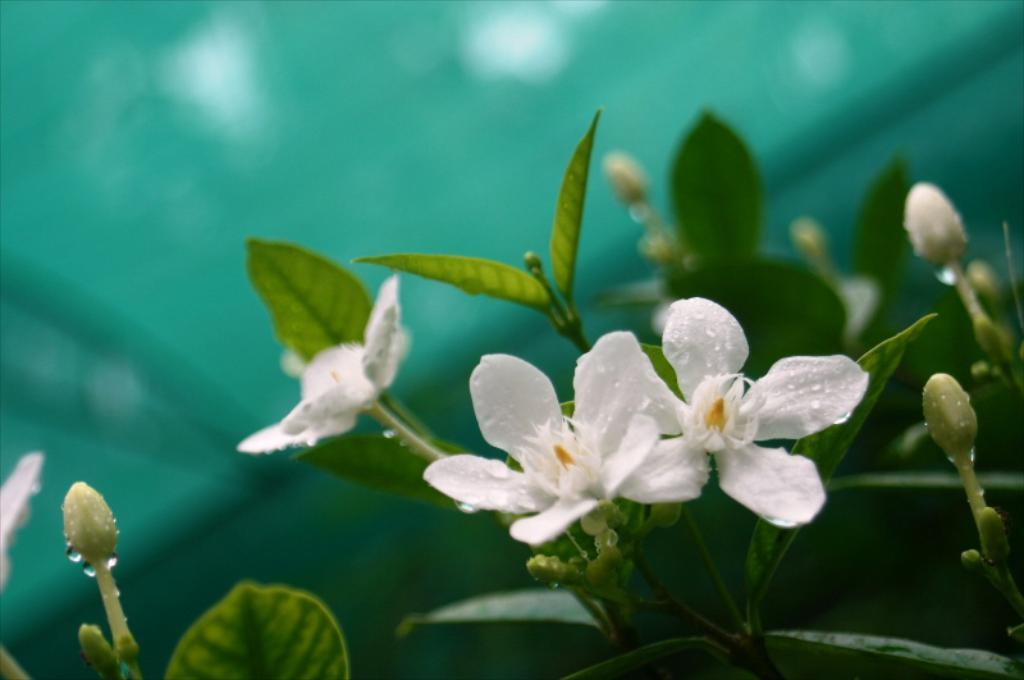What type of plant life is present in the image? There are flowers, leaves, and buds on stems in the image. Can you describe the condition of the flowers and buds? The flowers and buds have water droplets on them in the image. What is the background of the image like? The background of the image is blurry. Where is the vase located in the image? There is no vase present in the image. What type of locket can be seen hanging from the flowers in the image? There is no locket present in the image; it only features flowers, leaves, and buds with water droplets. 